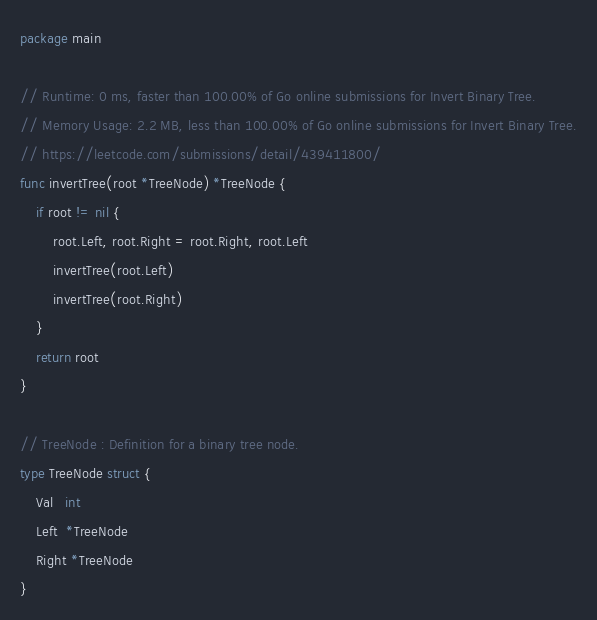<code> <loc_0><loc_0><loc_500><loc_500><_Go_>package main

// Runtime: 0 ms, faster than 100.00% of Go online submissions for Invert Binary Tree.
// Memory Usage: 2.2 MB, less than 100.00% of Go online submissions for Invert Binary Tree.
// https://leetcode.com/submissions/detail/439411800/
func invertTree(root *TreeNode) *TreeNode {
	if root != nil {
		root.Left, root.Right = root.Right, root.Left
		invertTree(root.Left)
		invertTree(root.Right)
	}
	return root
}

// TreeNode : Definition for a binary tree node.
type TreeNode struct {
	Val   int
	Left  *TreeNode
	Right *TreeNode
}
</code> 